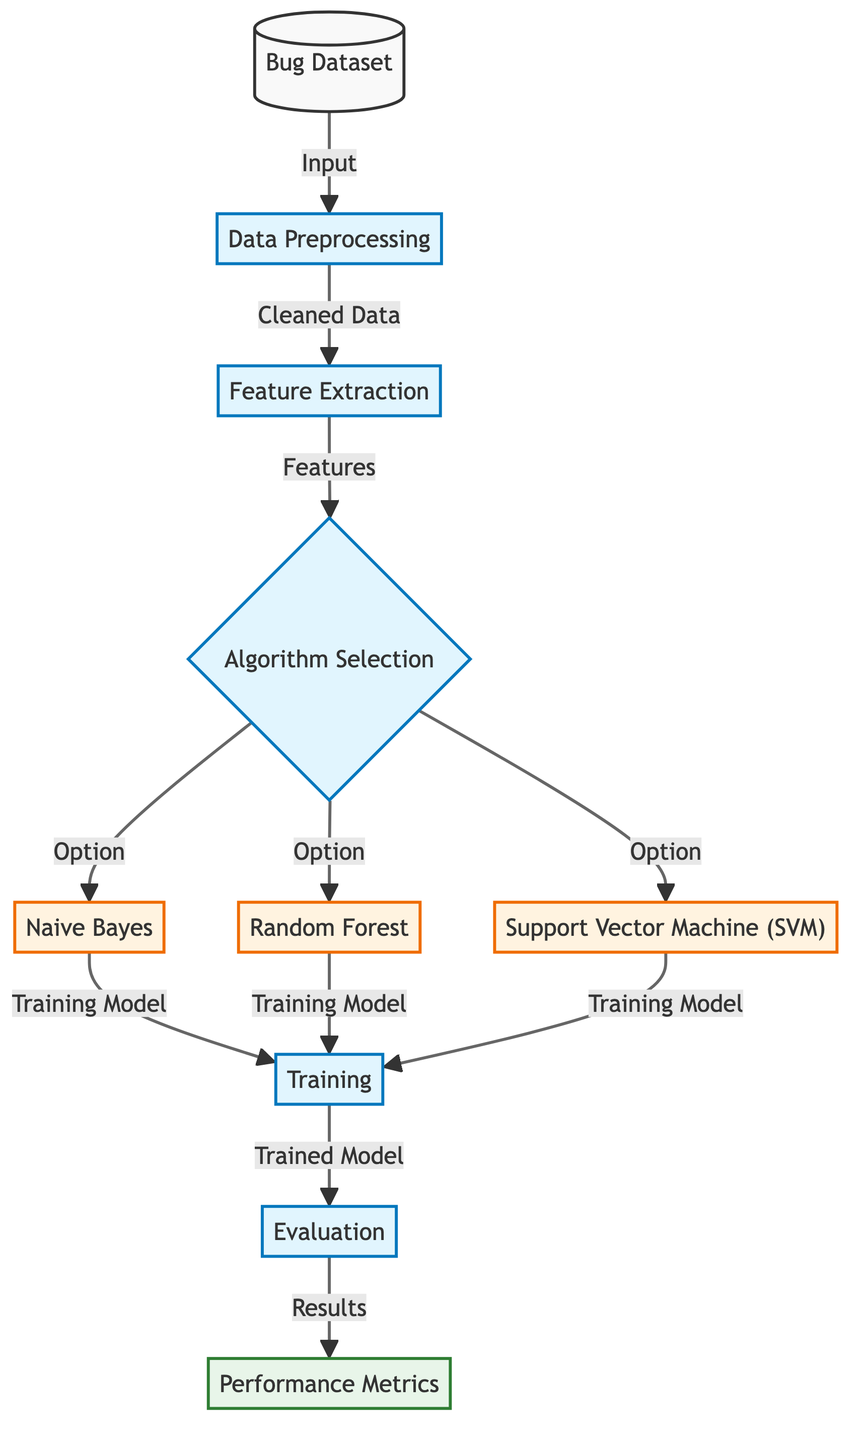What is the first process in the diagram? The first process in the diagram is "Data Preprocessing". It is directly connected as the first step that follows the "Bug Dataset" input.
Answer: Data Preprocessing How many algorithms are selected in the algorithm selection step? In the "Algorithm Selection" step, there are three algorithms shown: Naive Bayes, Random Forest, and Support Vector Machine (SVM).
Answer: Three What is the output of the evaluation process? The output of the evaluation process is labeled as "Results", which indicates the outcomes of evaluating the trained models.
Answer: Results Which process follows feature extraction? The process that follows "Feature Extraction" is "Algorithm Selection". This indicates the transition from extracting features to choosing a machine learning algorithm.
Answer: Algorithm Selection What is the final stage of the diagram? The final stage of the diagram is "Performance Metrics". This is the last output node that captures the evaluation result metrics for the models trained.
Answer: Performance Metrics Which algorithms are involved in the training stage? The algorithms involved in the "Training" stage include Naive Bayes, Random Forest, and Support Vector Machine (SVM). They are the selected algorithms that get trained subsequently.
Answer: Naive Bayes, Random Forest, Support Vector Machine What connects the data preprocessing process to feature extraction? The connection between "Data Preprocessing" and "Feature Extraction" is through the output of "Cleaned Data", which flows between these two processes.
Answer: Cleaned Data What type of diagram is this? The diagram is a "Machine Learning Diagram", as it illustrates the specific steps and algorithms used for bug detection in a machine learning context.
Answer: Machine Learning Diagram 